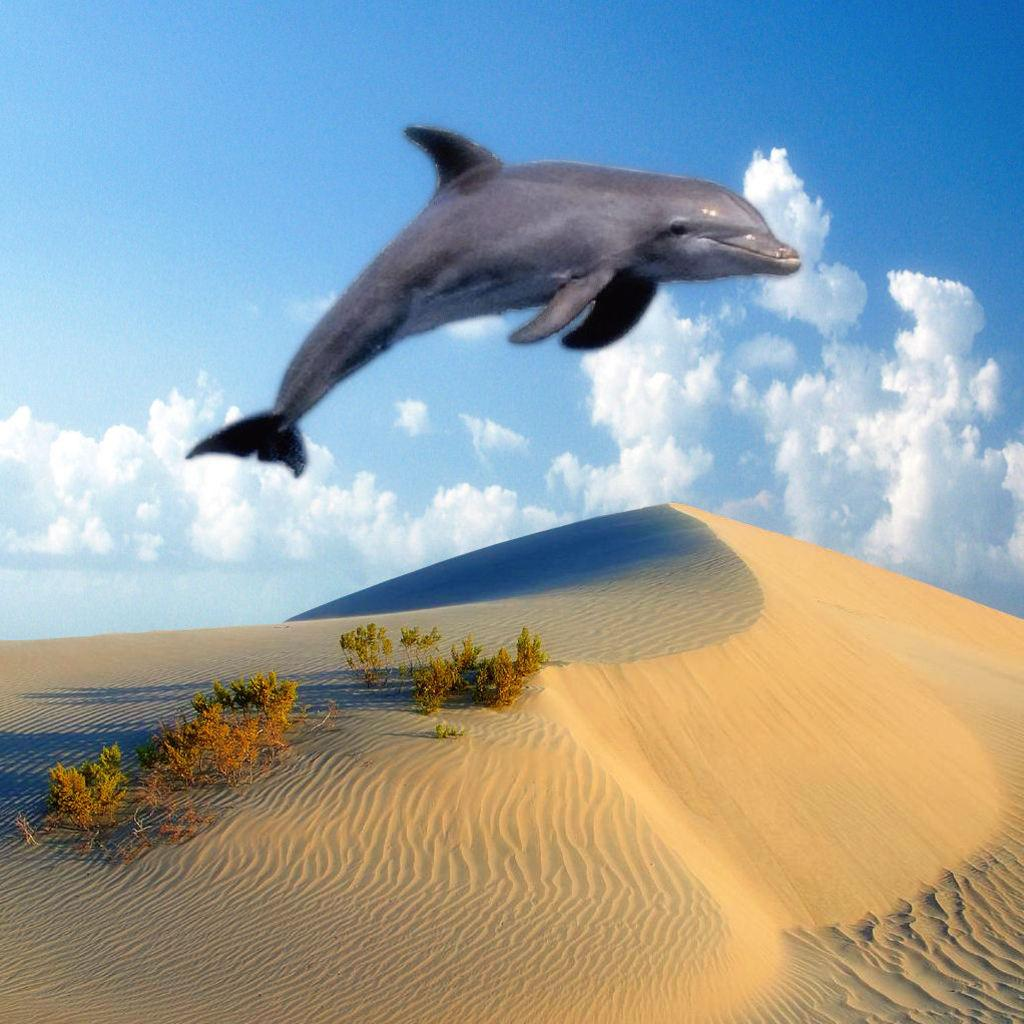What is at the bottom of the image? There is sand at the bottom of the image. What can be found growing in the sand? There are plants in the sand. What unusual event is happening in the image? A dolphin is in the air in the image. What can be seen in the background of the image? The sky is visible in the background of the image. What is the weather like in the image? The presence of clouds in the sky suggests that it might be partly cloudy. How many fingers can be seen stitching the rice in the image? There is no rice, fingers, or stitching present in the image. 